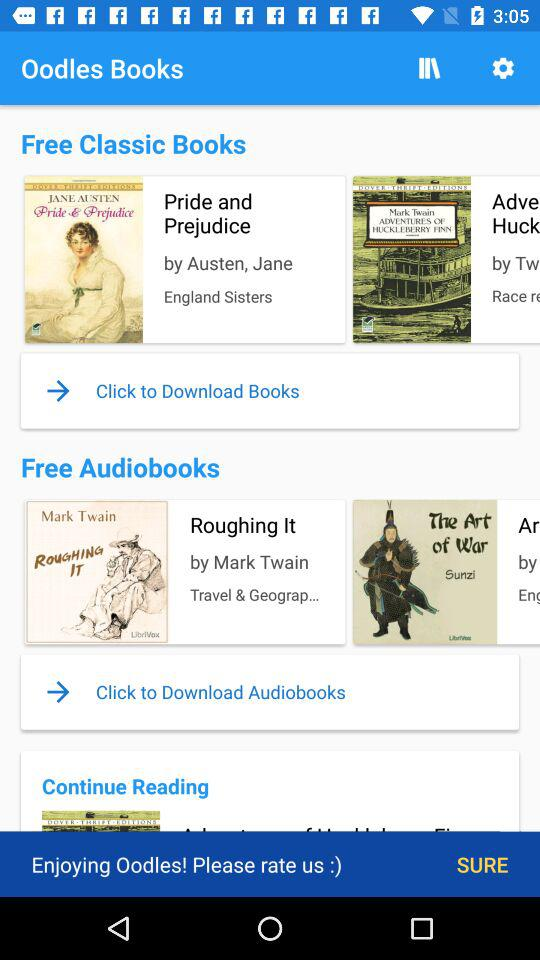Who's the author of the book "Pride and Prejudice"? The author of the book "Pride and Prejudice" is Jane Austen. 